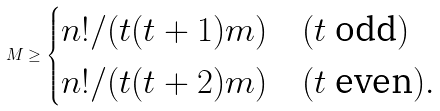Convert formula to latex. <formula><loc_0><loc_0><loc_500><loc_500>M \geq \begin{cases} n ! / ( t ( t + 1 ) m ) & ( t \text { odd} ) \\ n ! / ( t ( t + 2 ) m ) & ( t \text { even} ) . \end{cases}</formula> 